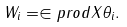Convert formula to latex. <formula><loc_0><loc_0><loc_500><loc_500>W _ { i } = \in p r o d { X } { \theta _ { i } } .</formula> 